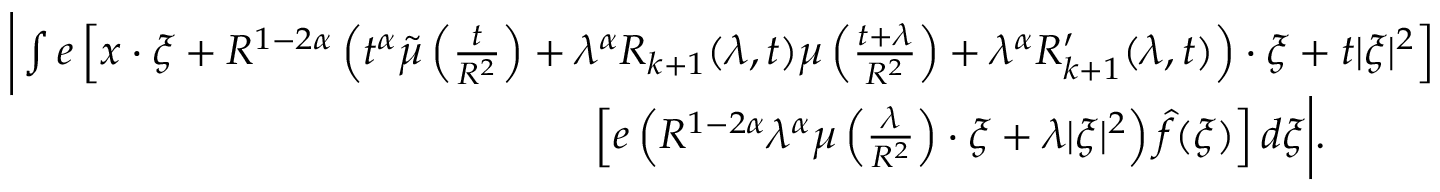<formula> <loc_0><loc_0><loc_500><loc_500>\begin{array} { r l } & { \left | \int e \left [ x \cdot \xi + R ^ { 1 - 2 \alpha } \left ( t ^ { \alpha } \tilde { \mu } \left ( \frac { t } { R ^ { 2 } } \right ) + \lambda ^ { \alpha } R _ { k + 1 } ( \lambda , t ) \mu \left ( \frac { t + \lambda } { R ^ { 2 } } \right ) + \lambda ^ { \alpha } R _ { k + 1 } ^ { \prime } ( \lambda , t ) \right ) \cdot \xi + t | \xi | ^ { 2 } \right ] } \\ & { \quad \left [ e \left ( R ^ { 1 - 2 \alpha } \lambda ^ { \alpha } \mu \left ( \frac { \lambda } { R ^ { 2 } } \right ) \cdot \xi + \lambda | \xi | ^ { 2 } \right ) \widehat { f } ( \xi ) \right ] d \xi \right | . } \end{array}</formula> 